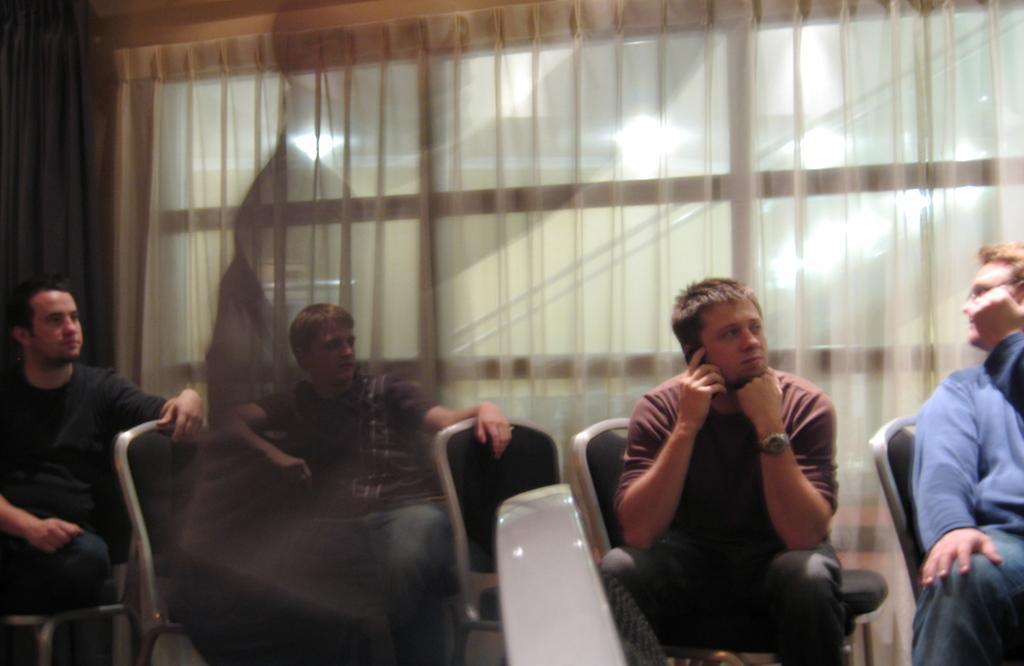Describe this image in one or two sentences. In this image there are group of persons sitting on the chair and at the middle of the image there is a person wearing red color shirt answering the phone. 